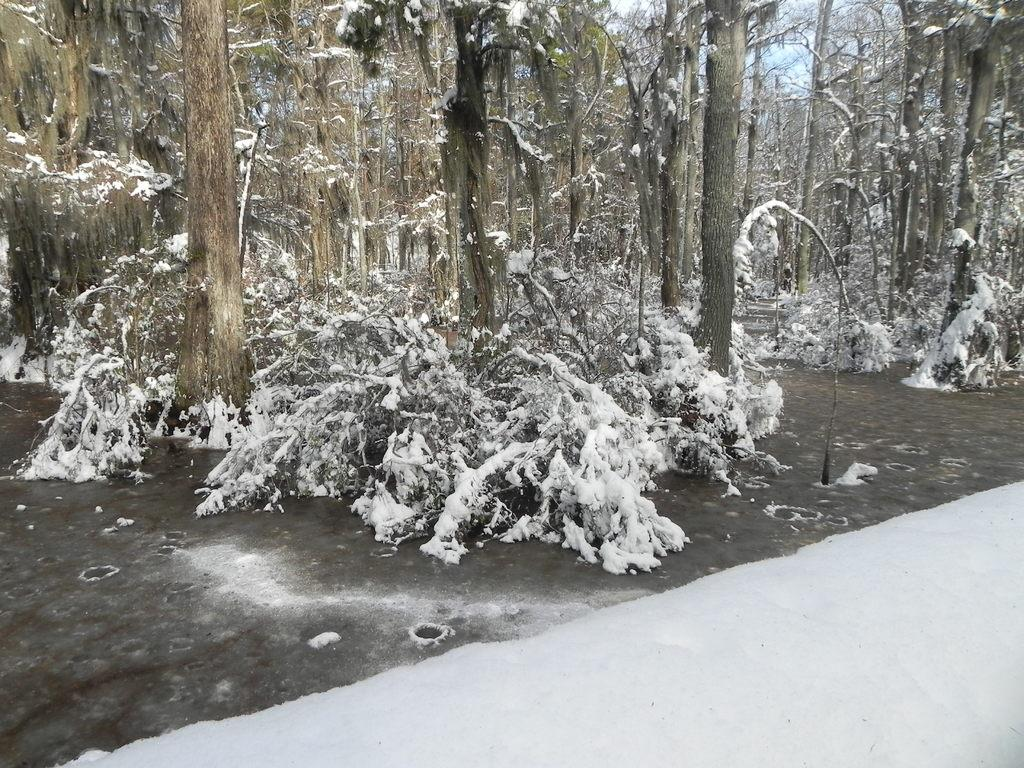What type of vegetation can be seen on the ground in the image? There are trees on the ground in the image. What is covering the ground in the image? Snow is visible in the image. What can be seen in the background of the image? The sky is visible in the background of the image. Can you see any clover growing in the snow in the image? There is no clover visible in the image; it only shows trees and snow on the ground. Is there a partner performing magic tricks in the image? There is no partner or magic tricks present in the image. 